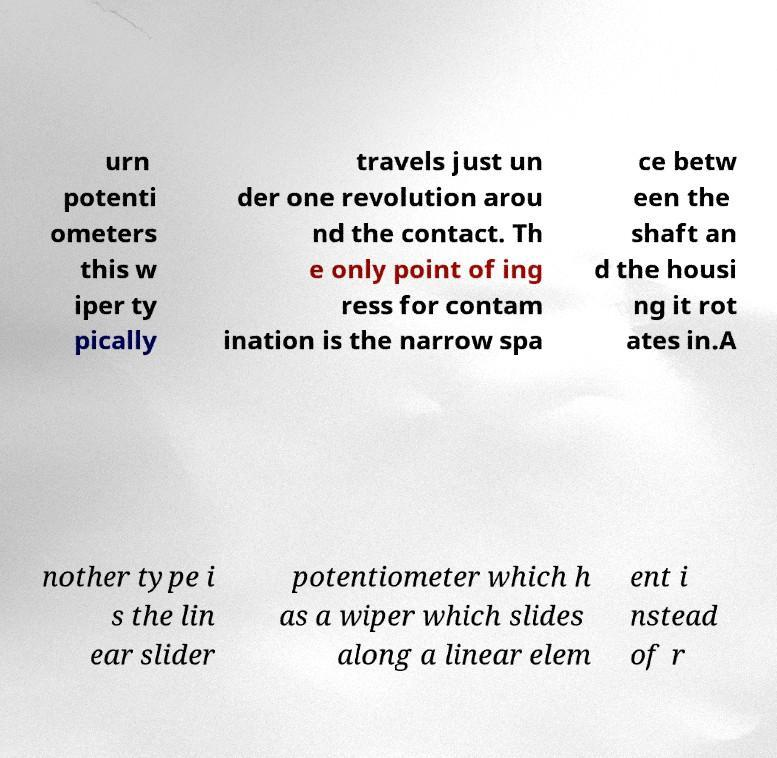For documentation purposes, I need the text within this image transcribed. Could you provide that? urn potenti ometers this w iper ty pically travels just un der one revolution arou nd the contact. Th e only point of ing ress for contam ination is the narrow spa ce betw een the shaft an d the housi ng it rot ates in.A nother type i s the lin ear slider potentiometer which h as a wiper which slides along a linear elem ent i nstead of r 